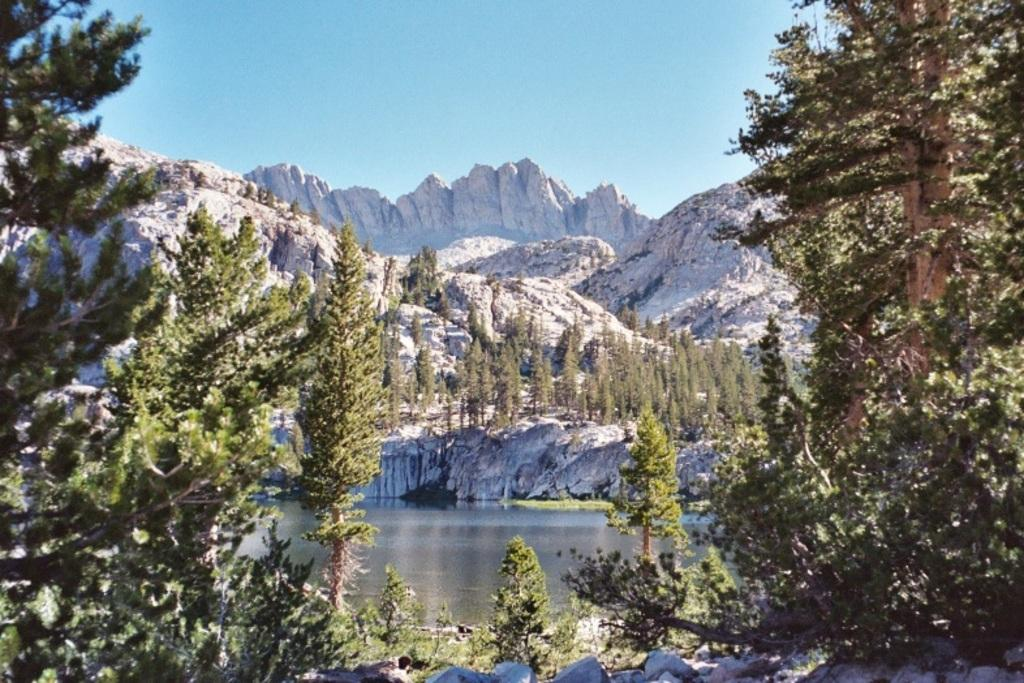What type of natural landform can be seen in the image? There are mountains in the image. What type of vegetation is present in the image? There are trees in the image. What body of water is visible in the image? There is water visible in the image. What part of the natural environment is visible in the image? The sky is visible in the image. Are there any giants visible in the image? There are no giants present in the image. What type of oil can be seen flowing from the mountains in the image? There is no oil visible in the image, and the mountains do not appear to be producing any oil. 